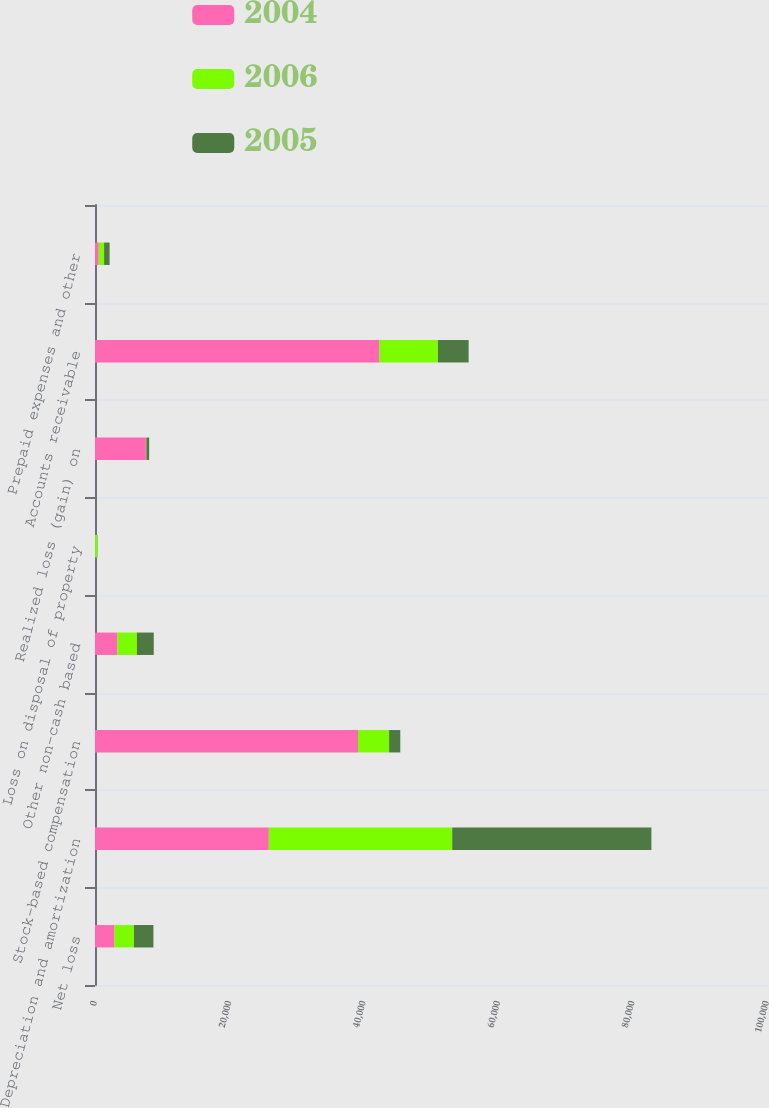Convert chart to OTSL. <chart><loc_0><loc_0><loc_500><loc_500><stacked_bar_chart><ecel><fcel>Net loss<fcel>Depreciation and amortization<fcel>Stock-based compensation<fcel>Other non-cash based<fcel>Loss on disposal of property<fcel>Realized loss (gain) on<fcel>Accounts receivable<fcel>Prepaid expenses and other<nl><fcel>2004<fcel>2898<fcel>25868<fcel>39137<fcel>3341<fcel>10<fcel>7579<fcel>42328<fcel>554<nl><fcel>2006<fcel>2898<fcel>27289<fcel>4632<fcel>2898<fcel>344<fcel>60<fcel>8704<fcel>802<nl><fcel>2005<fcel>2898<fcel>29640<fcel>1661<fcel>2504<fcel>43<fcel>423<fcel>4567<fcel>817<nl></chart> 